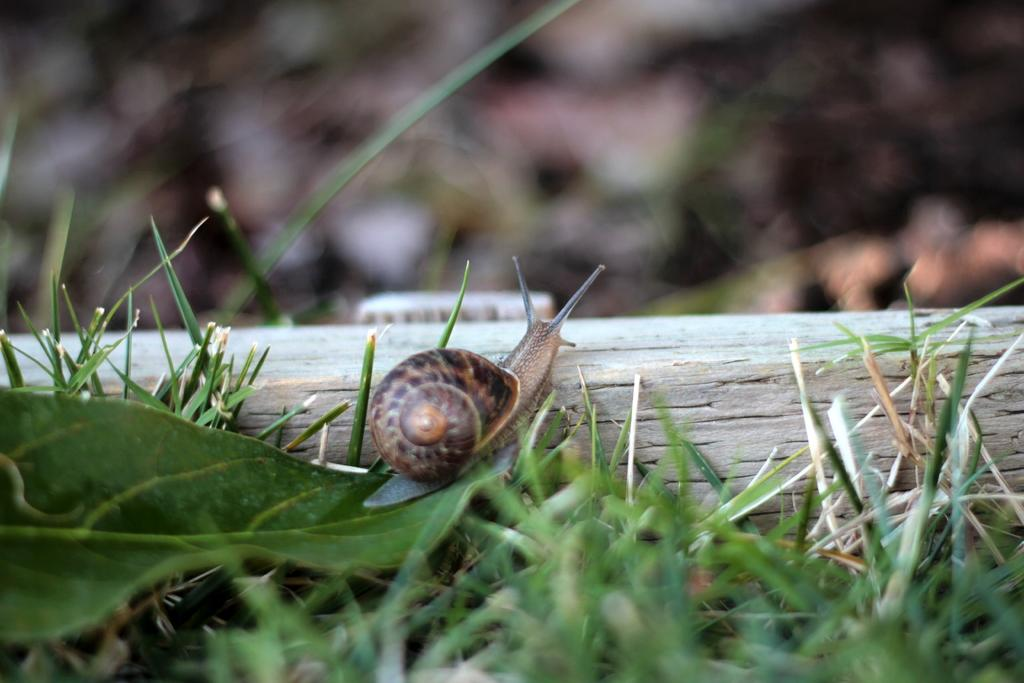What type of animal is in the image? There is a brown color snail in the image. What is the snail doing in the image? The snail is climbing on a wooden rafter. What type of vegetation can be seen in the image? Green leaves and grass are visible in the image. How many jellyfish are swimming in the grass in the image? There are no jellyfish present in the image; it features a snail climbing on a wooden rafter and vegetation. What type of waste can be seen in the image? There is no waste visible in the image. 